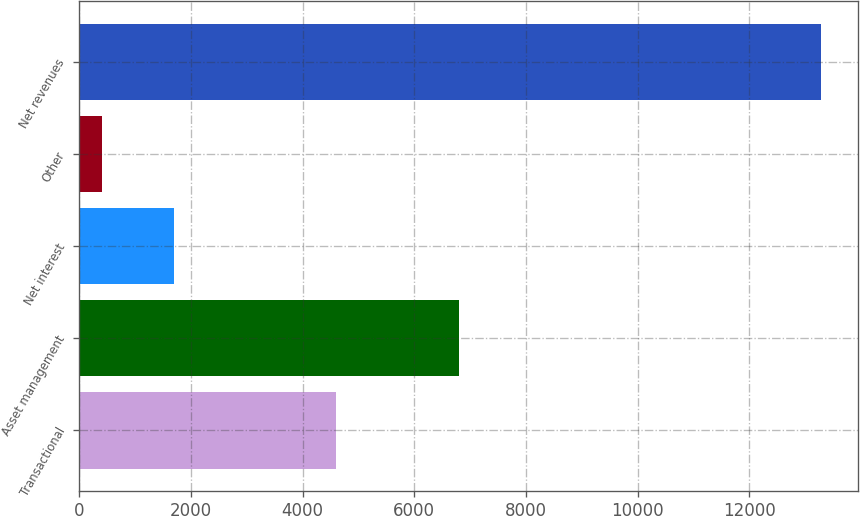Convert chart. <chart><loc_0><loc_0><loc_500><loc_500><bar_chart><fcel>Transactional<fcel>Asset management<fcel>Net interest<fcel>Other<fcel>Net revenues<nl><fcel>4606<fcel>6792<fcel>1701.5<fcel>414<fcel>13289<nl></chart> 